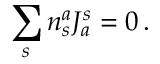<formula> <loc_0><loc_0><loc_500><loc_500>\sum _ { s } n _ { s } ^ { a } J _ { a } ^ { s } = 0 \, .</formula> 